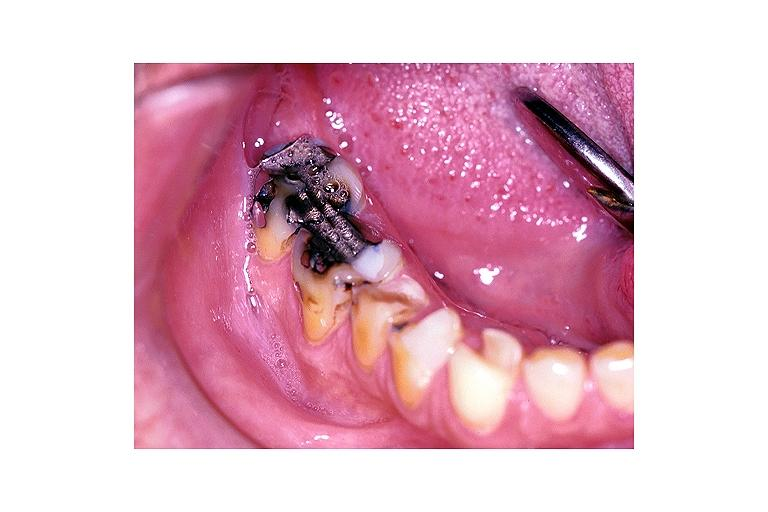what is present?
Answer the question using a single word or phrase. Oral 